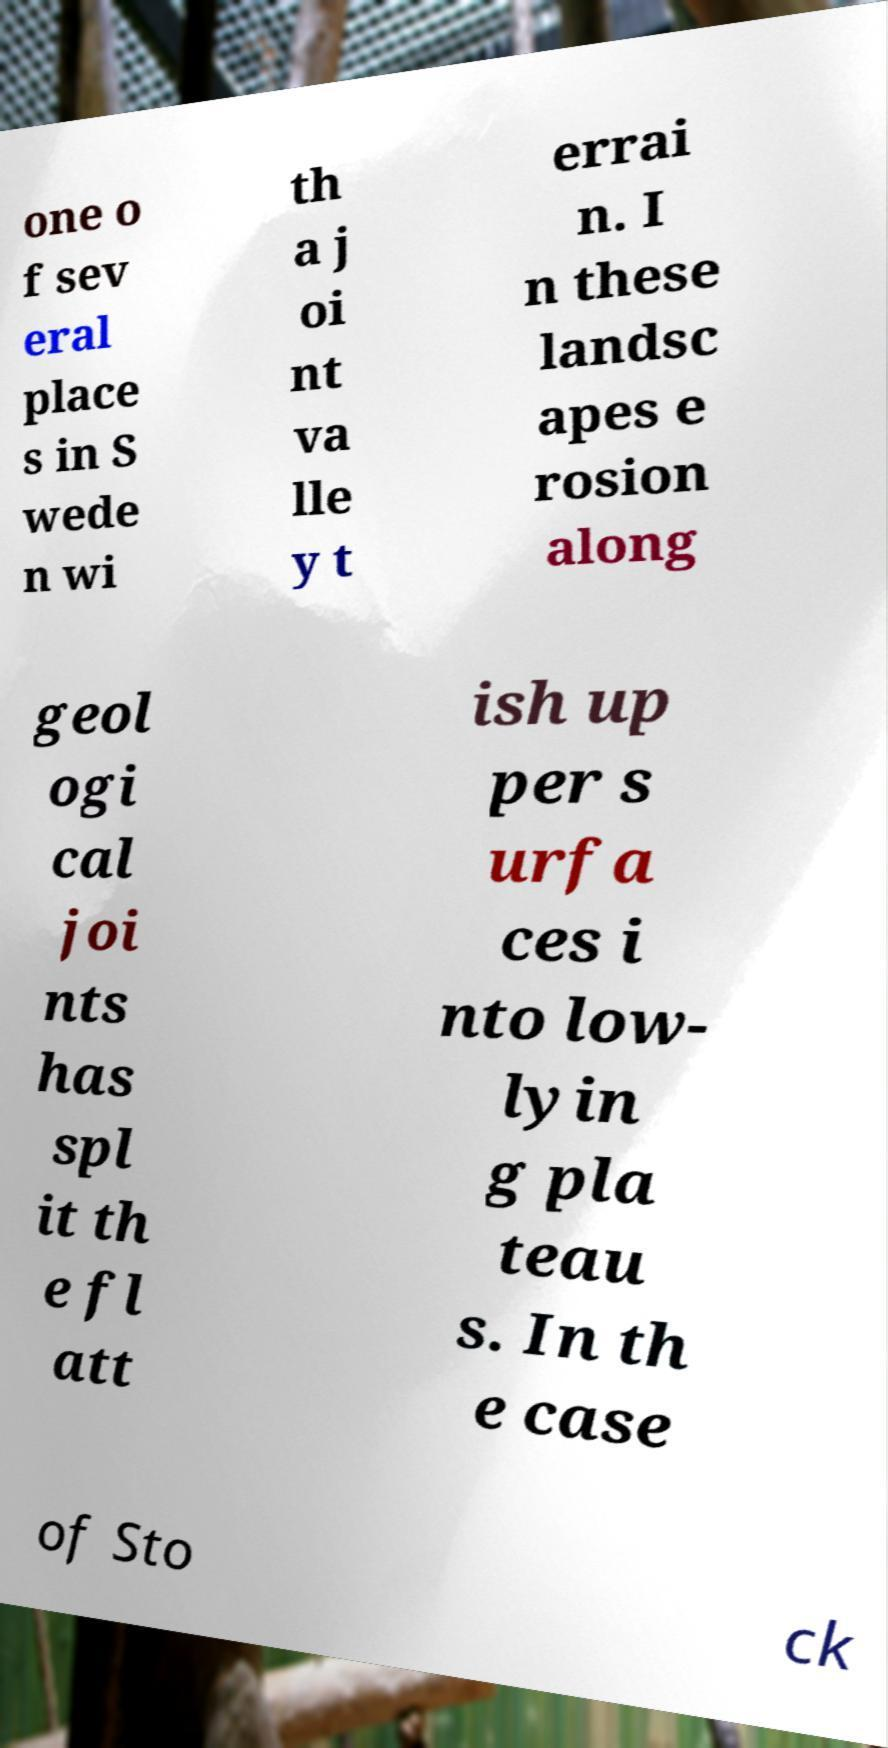Could you assist in decoding the text presented in this image and type it out clearly? one o f sev eral place s in S wede n wi th a j oi nt va lle y t errai n. I n these landsc apes e rosion along geol ogi cal joi nts has spl it th e fl att ish up per s urfa ces i nto low- lyin g pla teau s. In th e case of Sto ck 